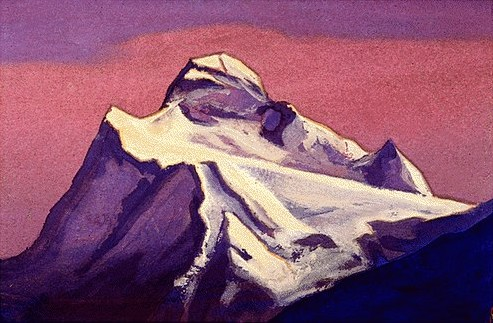Analyze the image in a comprehensive and detailed manner. The image features a stunning, impressionistic painting of a towering mountain peak, rendered with a delicate touch. The mountain itself is cloaked in a palette of white and gray, standing majestically against a backdrop of a sky suffused with rich purples and pinks, suggestive of either dawn or dusk. Shadows in varying shades of blue spill down the mountain's slopes, giving it a palpable sense of depth and volume. The artistry showcased here is undeniably impressionistic, characterized by loose and expressive brushwork that captures the ephemeral beauty and serenity of nature. This landscape painting invites viewers to lose themselves in the tranquil and majestic presence of the mountain, appreciating the harmonious blend of light, color, and texture. 